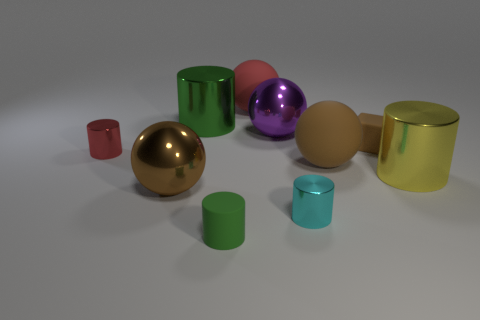There is a metal ball that is to the right of the tiny matte cylinder; is its color the same as the cylinder that is behind the tiny red object?
Provide a succinct answer. No. What number of yellow metallic cylinders are the same size as the purple sphere?
Ensure brevity in your answer.  1. There is a metallic object in front of the brown shiny thing; is it the same size as the purple metal ball?
Offer a terse response. No. There is a small brown matte thing; what shape is it?
Offer a terse response. Cube. What is the size of the other cylinder that is the same color as the tiny matte cylinder?
Provide a short and direct response. Large. Is the big cylinder on the left side of the matte block made of the same material as the tiny red thing?
Provide a succinct answer. Yes. Are there any big objects that have the same color as the rubber block?
Offer a terse response. Yes. There is a brown thing that is in front of the large brown rubber ball; does it have the same shape as the red object left of the tiny green matte cylinder?
Make the answer very short. No. Is there a small green cube made of the same material as the large green cylinder?
Your answer should be compact. No. What number of brown things are big matte balls or big metal things?
Ensure brevity in your answer.  2. 